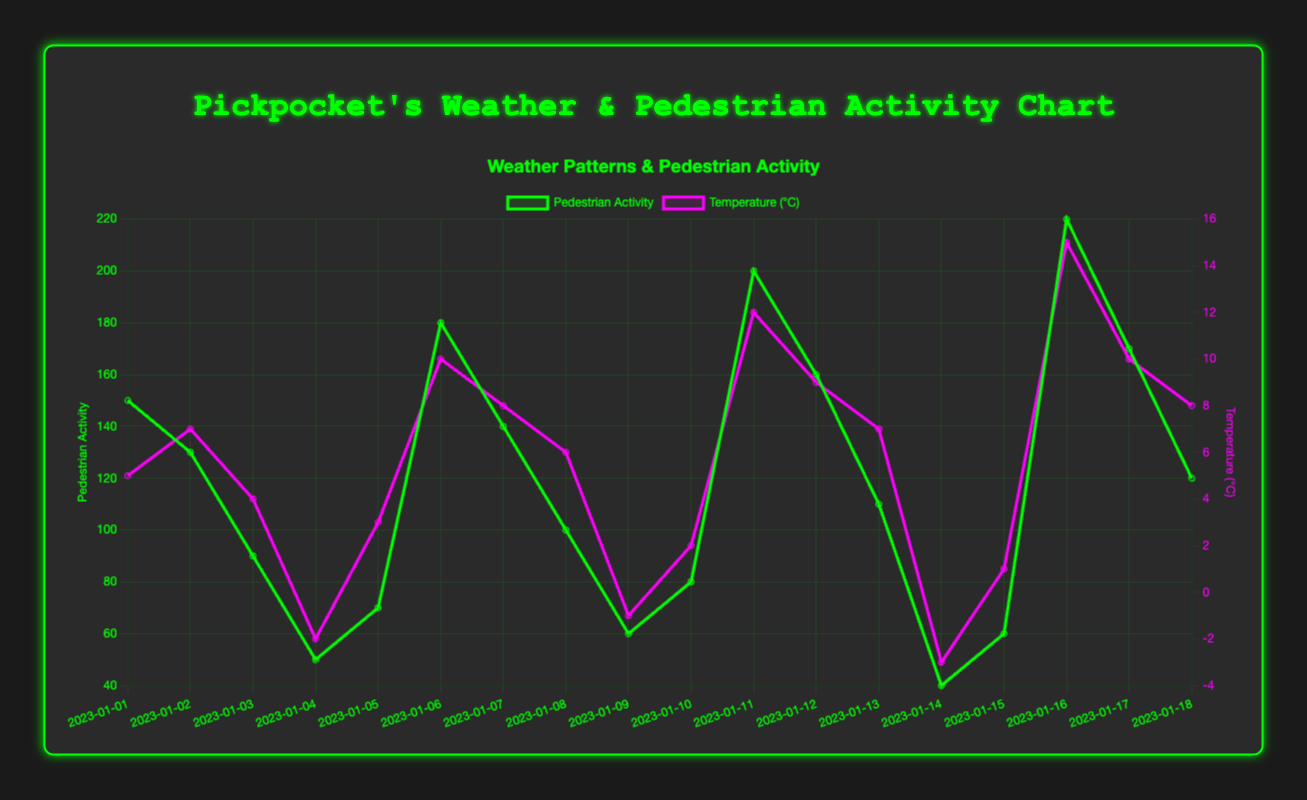Which weather condition has the highest pedestrian activity? By looking at the curve, it is clear that the highest pedestrian activity occurs on dates with "Sunny" weather conditions.
Answer: Sunny What is the difference in pedestrian activity between the first "Sunny" day and the first "Cloudy" day? The pedestrian activity on the first "Sunny" day is 150, and on the first "Cloudy" day, it is 130. The difference is 150 - 130 = 20.
Answer: 20 What is the average pedestrian activity for "Snowy" weather days? There are four "Snowy" weather days with pedestrian activities of 50, 60, 40, and 60. The sum is 50 + 60 + 40 + 60 = 210. Average is 210 / 4 = 52.5.
Answer: 52.5 On which date does the temperature peak, and what is the pedestrian activity on that date? The highest temperature peak occurs on 2023-01-16 with a temperature of 15°C. On this date, the pedestrian activity is 220.
Answer: 2023-01-16, 220 Which temperature condition corresponds to the highest pedestrian activity and what is that activity level? The highest pedestrian activity, which is 220, corresponds to a temperature condition of 15°C.
Answer: 15°C, 220 How does pedestrian activity change from the "Rainy" day on 2023-01-03 to the "Rainy" day on 2023-01-13? Pedestrian activity changes from 90 on 2023-01-03 to 110 on 2023-01-13. The change is 110 - 90 = 20.
Answer: Increase by 20 What is the pedestrian activity on the day with the lowest temperature? The lowest temperature is -3°C on 2023-01-14, and the pedestrian activity on that day is 40.
Answer: 40 On which dates do both temperature and pedestrian activity show an increasing trend? An increasing trend is observed from 2023-01-15 to 2023-01-18, with temperatures increasing from 1°C to 8°C and pedestrian activity increasing from 60 to 120.
Answer: 2023-01-15 to 2023-01-18 Compare pedestrian activity levels between the first "Windy" day and the last "Windy" day. The pedestrian activity on the first "Windy" day (2023-01-05) is 70, and on the last "Windy" day (2023-01-15), it is 60. The first "Windy" day has higher pedestrian activity.
Answer: The first "Windy" day Which weather condition shows the most consistent relationship with pedestrian activity levels, and why? "Sunny" conditions show the most consistent high pedestrian activities, consistently showing higher activity levels compared to other weather conditions.
Answer: Sunny, higher activity levels 